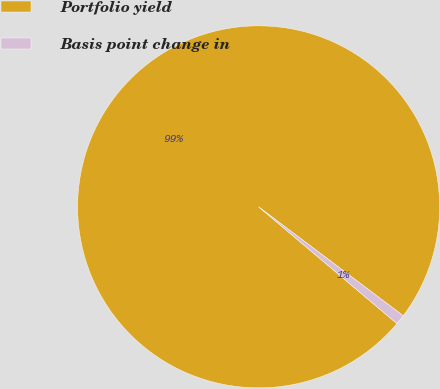<chart> <loc_0><loc_0><loc_500><loc_500><pie_chart><fcel>Portfolio yield<fcel>Basis point change in<nl><fcel>99.11%<fcel>0.89%<nl></chart> 